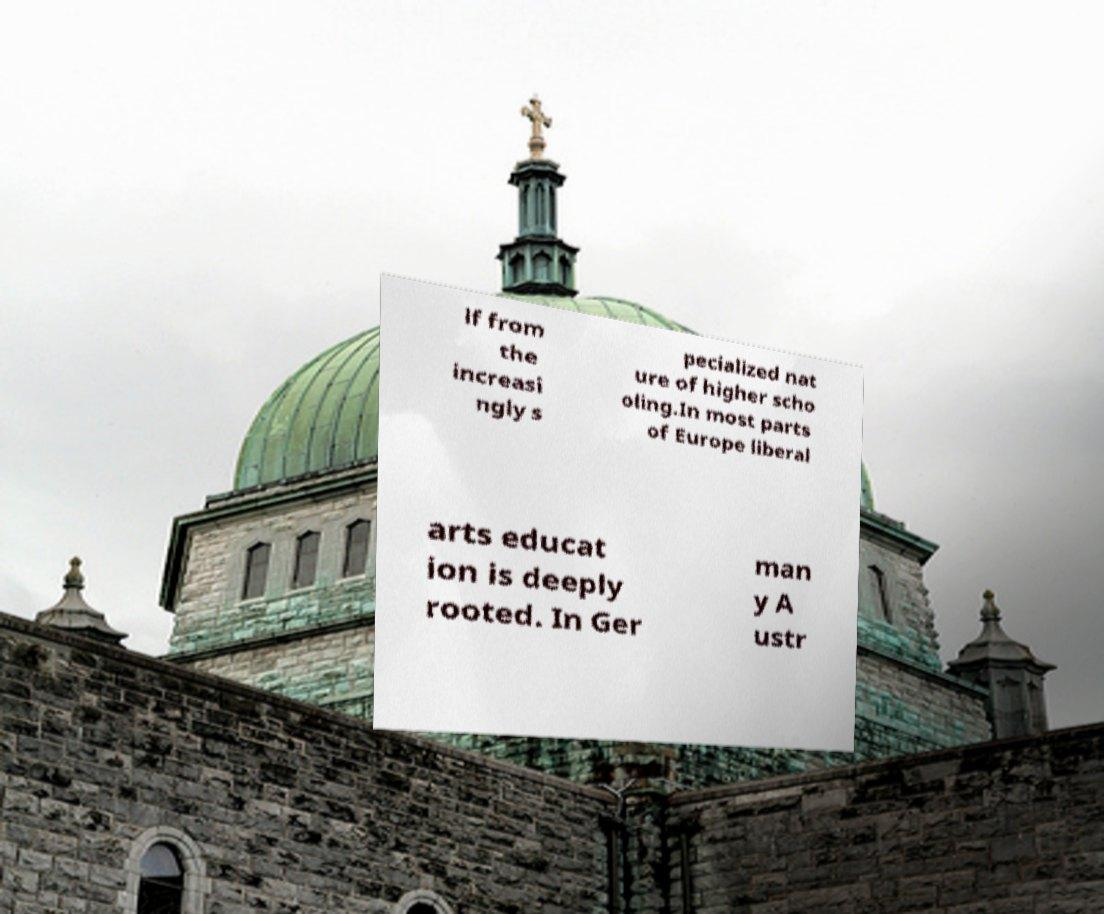I need the written content from this picture converted into text. Can you do that? lf from the increasi ngly s pecialized nat ure of higher scho oling.In most parts of Europe liberal arts educat ion is deeply rooted. In Ger man y A ustr 